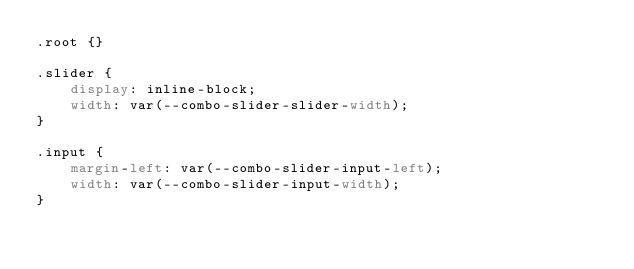Convert code to text. <code><loc_0><loc_0><loc_500><loc_500><_CSS_>.root {}

.slider {
    display: inline-block;
    width: var(--combo-slider-slider-width);
}

.input {
    margin-left: var(--combo-slider-input-left);
    width: var(--combo-slider-input-width);
}
</code> 